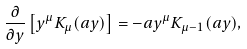<formula> <loc_0><loc_0><loc_500><loc_500>\frac { \partial } { \partial y } \left [ y ^ { \mu } K _ { \mu } ( a y ) \right ] = - a y ^ { \mu } K _ { \mu - 1 } ( a y ) ,</formula> 